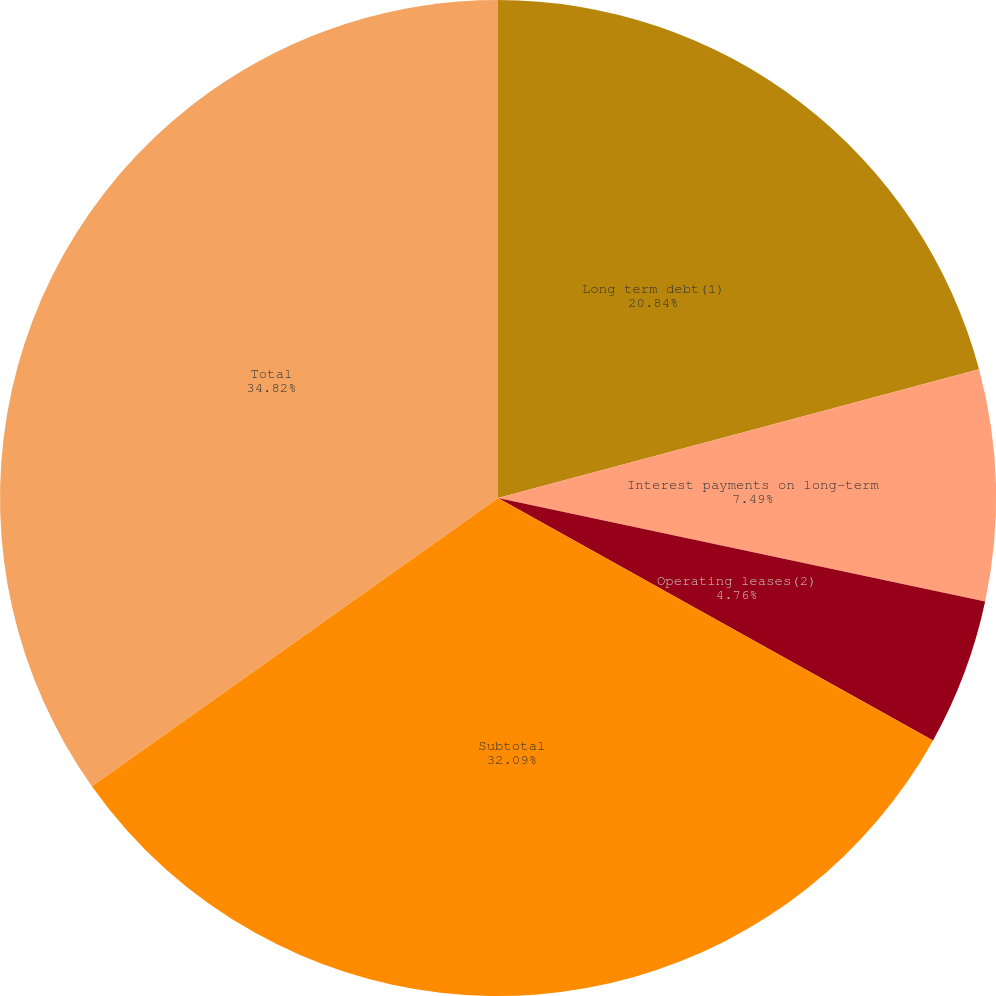Convert chart. <chart><loc_0><loc_0><loc_500><loc_500><pie_chart><fcel>Long term debt(1)<fcel>Interest payments on long-term<fcel>Operating leases(2)<fcel>Subtotal<fcel>Total<nl><fcel>20.84%<fcel>7.49%<fcel>4.76%<fcel>32.09%<fcel>34.82%<nl></chart> 